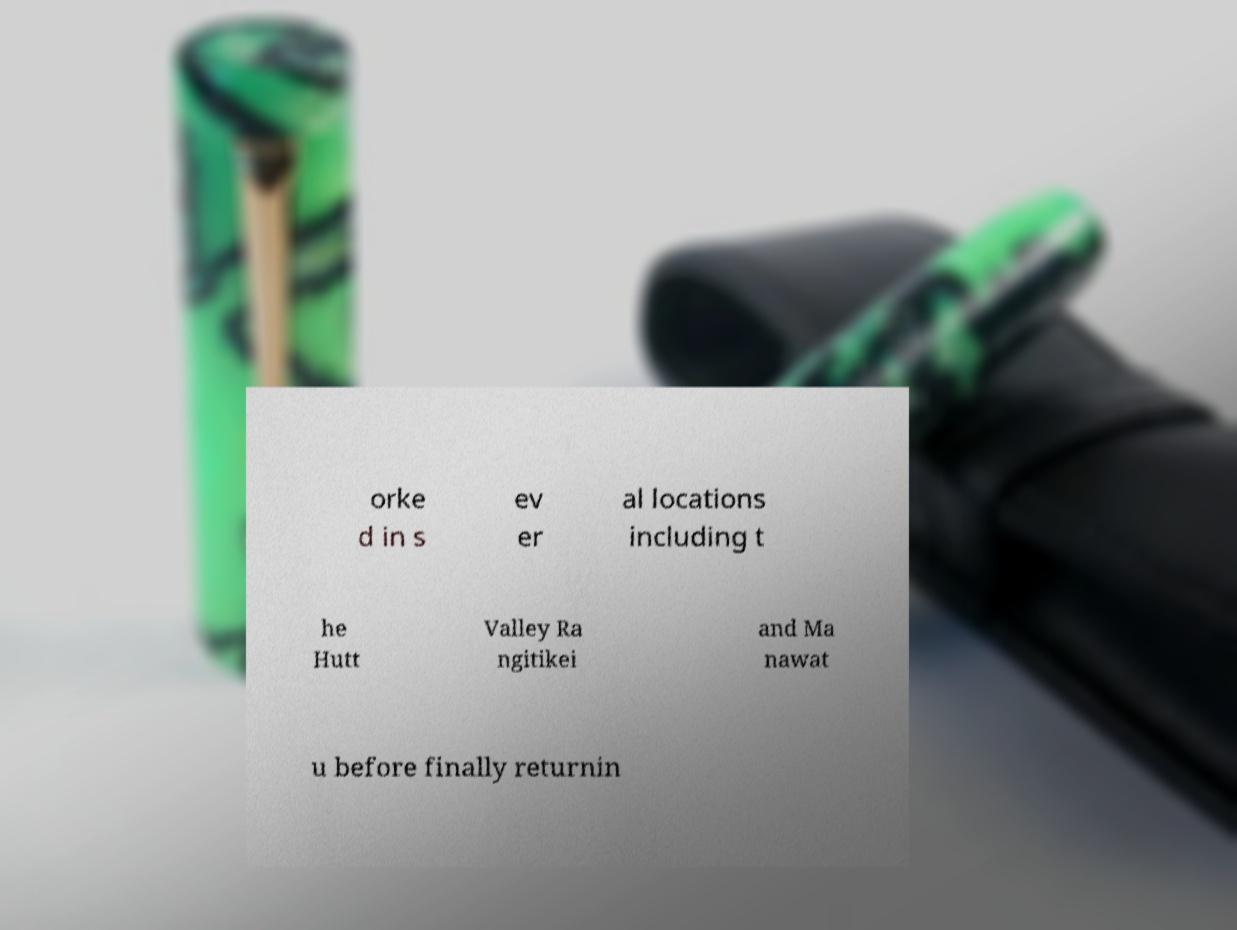What messages or text are displayed in this image? I need them in a readable, typed format. orke d in s ev er al locations including t he Hutt Valley Ra ngitikei and Ma nawat u before finally returnin 